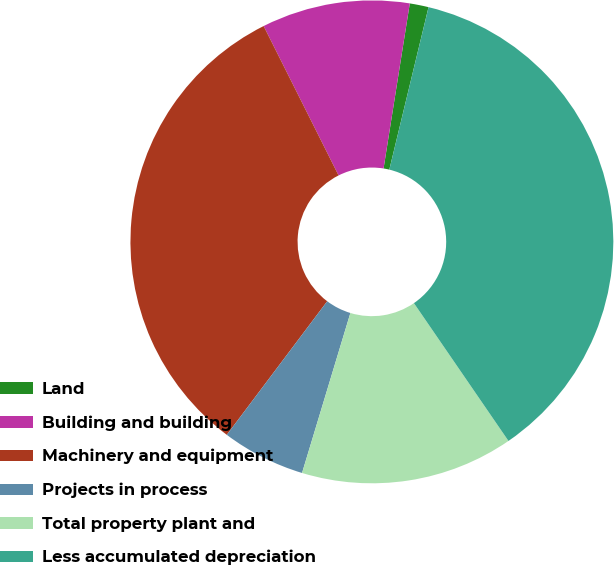Convert chart. <chart><loc_0><loc_0><loc_500><loc_500><pie_chart><fcel>Land<fcel>Building and building<fcel>Machinery and equipment<fcel>Projects in process<fcel>Total property plant and<fcel>Less accumulated depreciation<nl><fcel>1.26%<fcel>9.91%<fcel>32.34%<fcel>5.59%<fcel>14.24%<fcel>36.66%<nl></chart> 